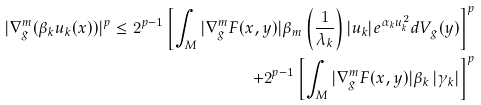Convert formula to latex. <formula><loc_0><loc_0><loc_500><loc_500>| \nabla _ { g } ^ { m } ( \beta _ { k } u _ { k } ( x ) ) | ^ { p } \leq 2 ^ { p - 1 } \left [ \int _ { M } | \nabla _ { g } ^ { m } F ( x , y ) | \beta _ { m } \left ( \frac { 1 } { \lambda _ { k } } \right ) | u _ { k } | e ^ { \alpha _ { k } u _ { k } ^ { 2 } } d V _ { g } ( y ) \right ] ^ { p } \\ + 2 ^ { p - 1 } \left [ \int _ { M } | \nabla _ { g } ^ { m } F ( x , y ) | \beta _ { k } \left | \gamma _ { k } \right | \right ] ^ { p }</formula> 